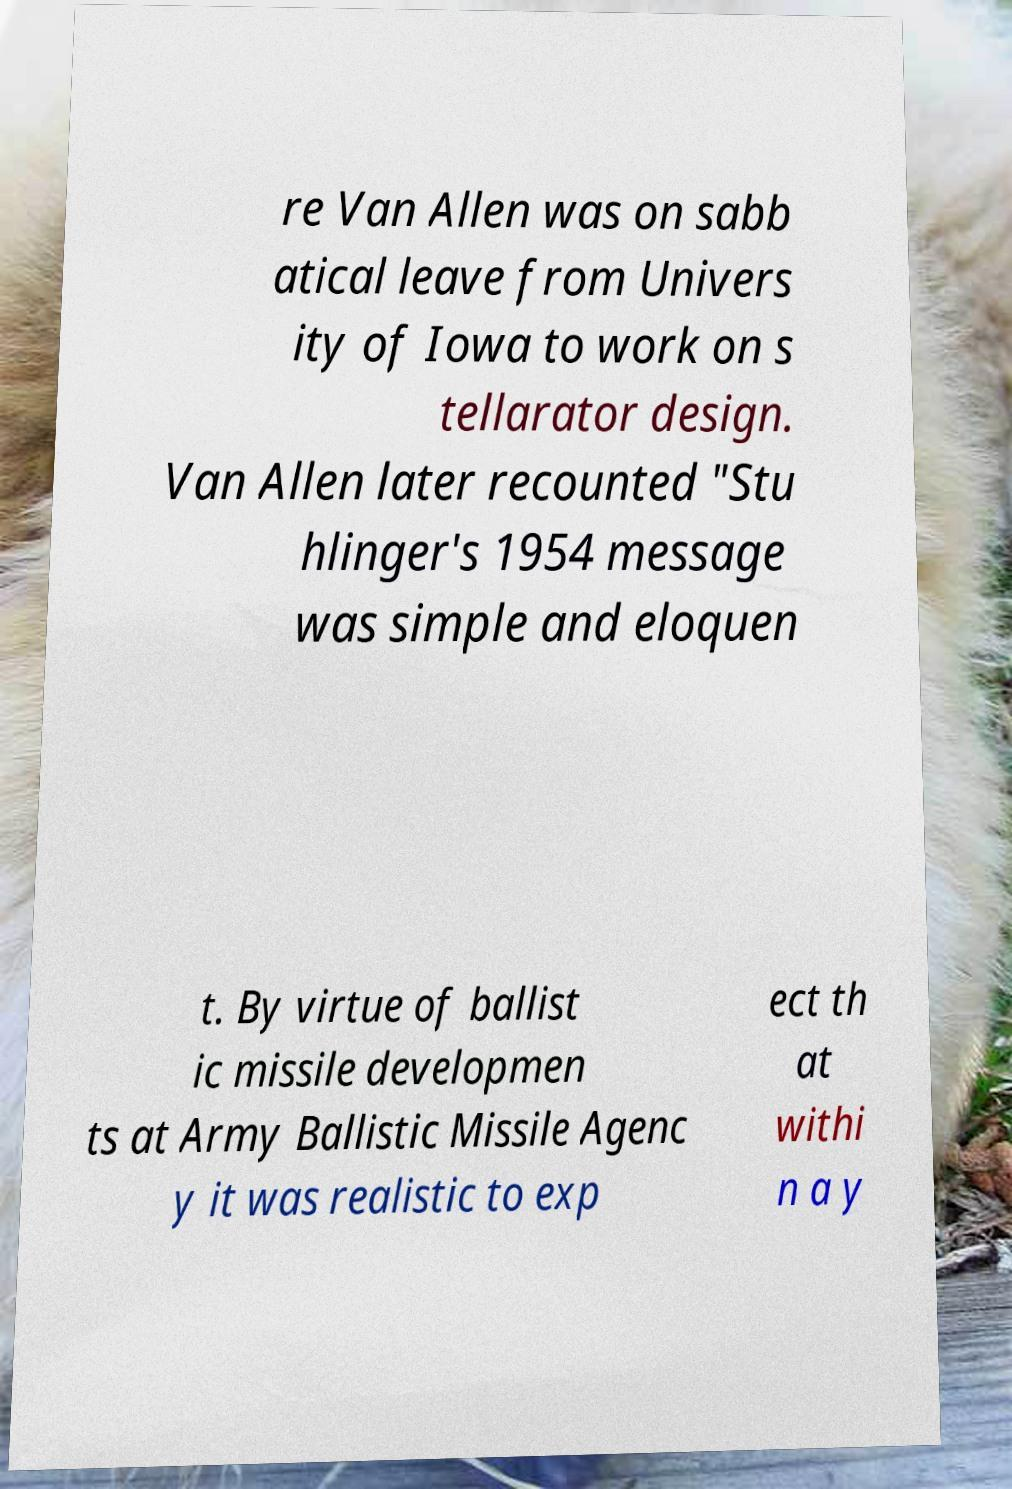For documentation purposes, I need the text within this image transcribed. Could you provide that? re Van Allen was on sabb atical leave from Univers ity of Iowa to work on s tellarator design. Van Allen later recounted "Stu hlinger's 1954 message was simple and eloquen t. By virtue of ballist ic missile developmen ts at Army Ballistic Missile Agenc y it was realistic to exp ect th at withi n a y 